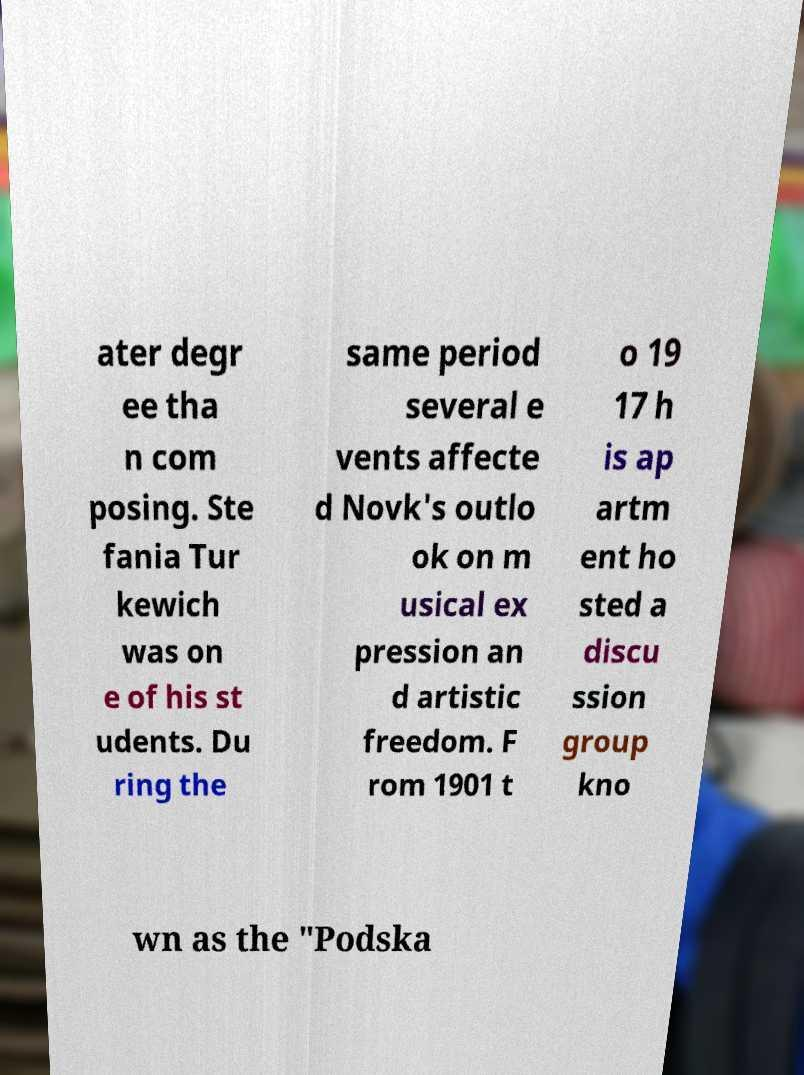I need the written content from this picture converted into text. Can you do that? ater degr ee tha n com posing. Ste fania Tur kewich was on e of his st udents. Du ring the same period several e vents affecte d Novk's outlo ok on m usical ex pression an d artistic freedom. F rom 1901 t o 19 17 h is ap artm ent ho sted a discu ssion group kno wn as the "Podska 